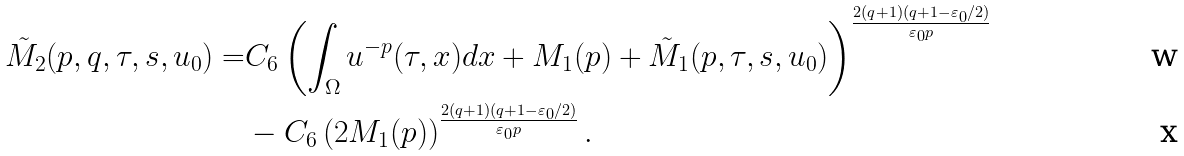<formula> <loc_0><loc_0><loc_500><loc_500>\tilde { M } _ { 2 } ( p , q , \tau , s , u _ { 0 } ) = & C _ { 6 } \left ( \int _ { \Omega } u ^ { - p } ( \tau , x ) d x + M _ { 1 } ( p ) + \tilde { M } _ { 1 } ( p , \tau , s , u _ { 0 } ) \right ) ^ { \frac { 2 ( q + 1 ) ( q + 1 - \varepsilon _ { 0 } / 2 ) } { \varepsilon _ { 0 } p } } \\ & - C _ { 6 } \left ( 2 M _ { 1 } ( p ) \right ) ^ { \frac { 2 ( q + 1 ) ( q + 1 - \varepsilon _ { 0 } / 2 ) } { \varepsilon _ { 0 } p } } .</formula> 